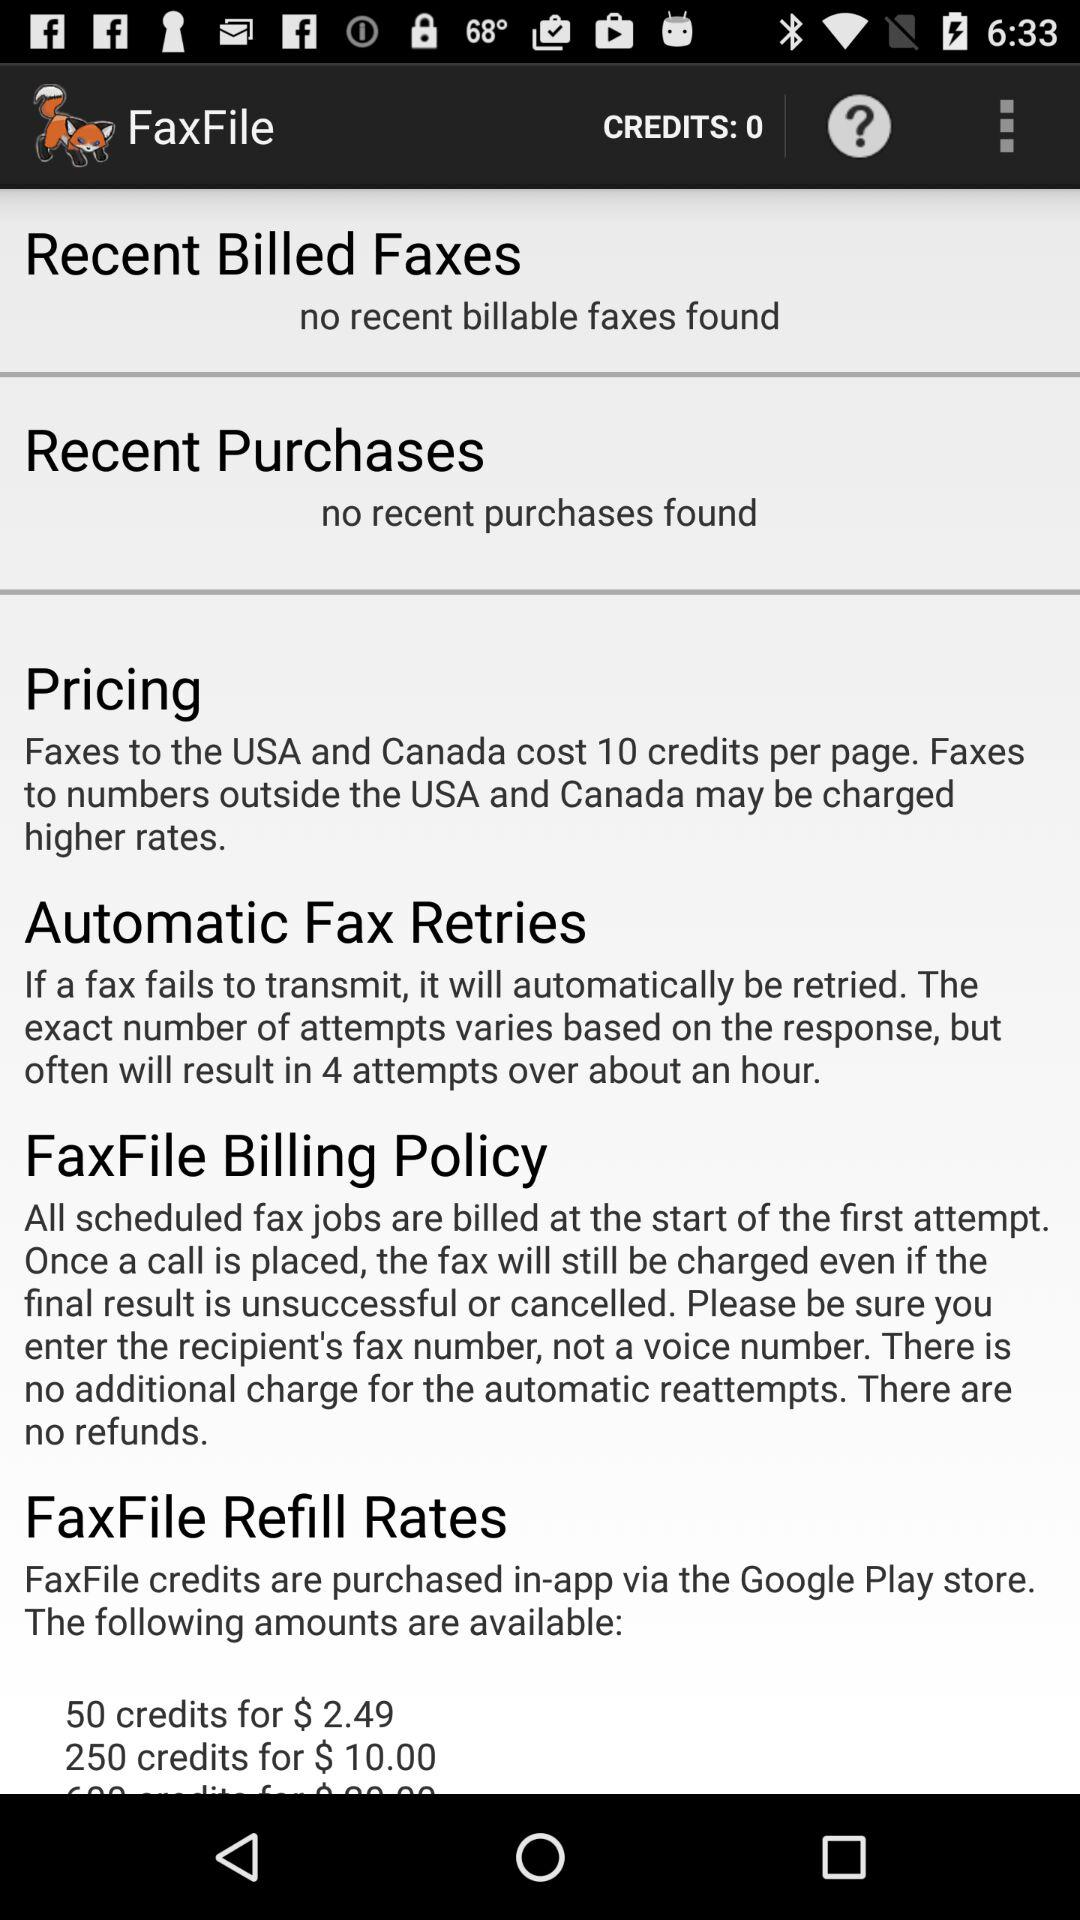Is there any Recent Billed Faxes found? There is no recent billable faxes found. 